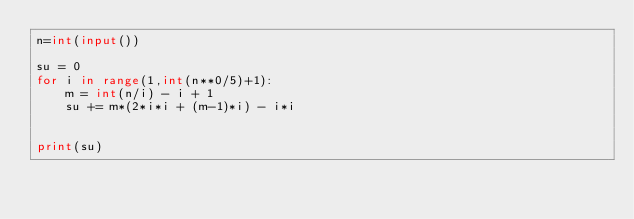Convert code to text. <code><loc_0><loc_0><loc_500><loc_500><_Python_>n=int(input())
 
su = 0
for i in range(1,int(n**0/5)+1):
    m = int(n/i) - i + 1
    su += m*(2*i*i + (m-1)*i) - i*i
    
 
print(su)</code> 